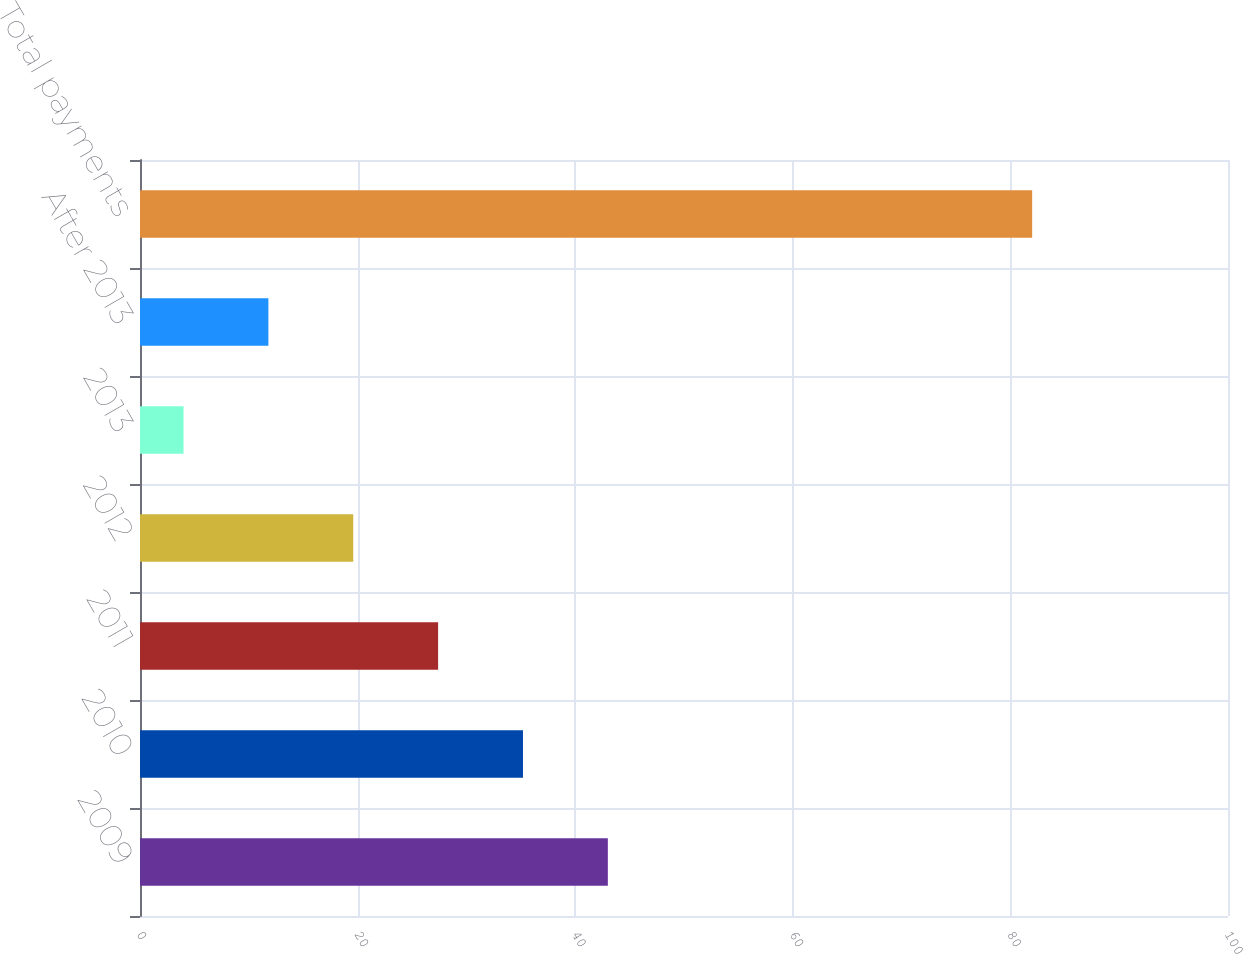<chart> <loc_0><loc_0><loc_500><loc_500><bar_chart><fcel>2009<fcel>2010<fcel>2011<fcel>2012<fcel>2013<fcel>After 2013<fcel>Total payments<nl><fcel>43<fcel>35.2<fcel>27.4<fcel>19.6<fcel>4<fcel>11.8<fcel>82<nl></chart> 